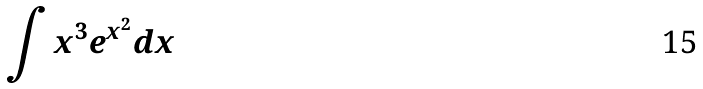Convert formula to latex. <formula><loc_0><loc_0><loc_500><loc_500>\int x ^ { 3 } e ^ { x ^ { 2 } } d x</formula> 